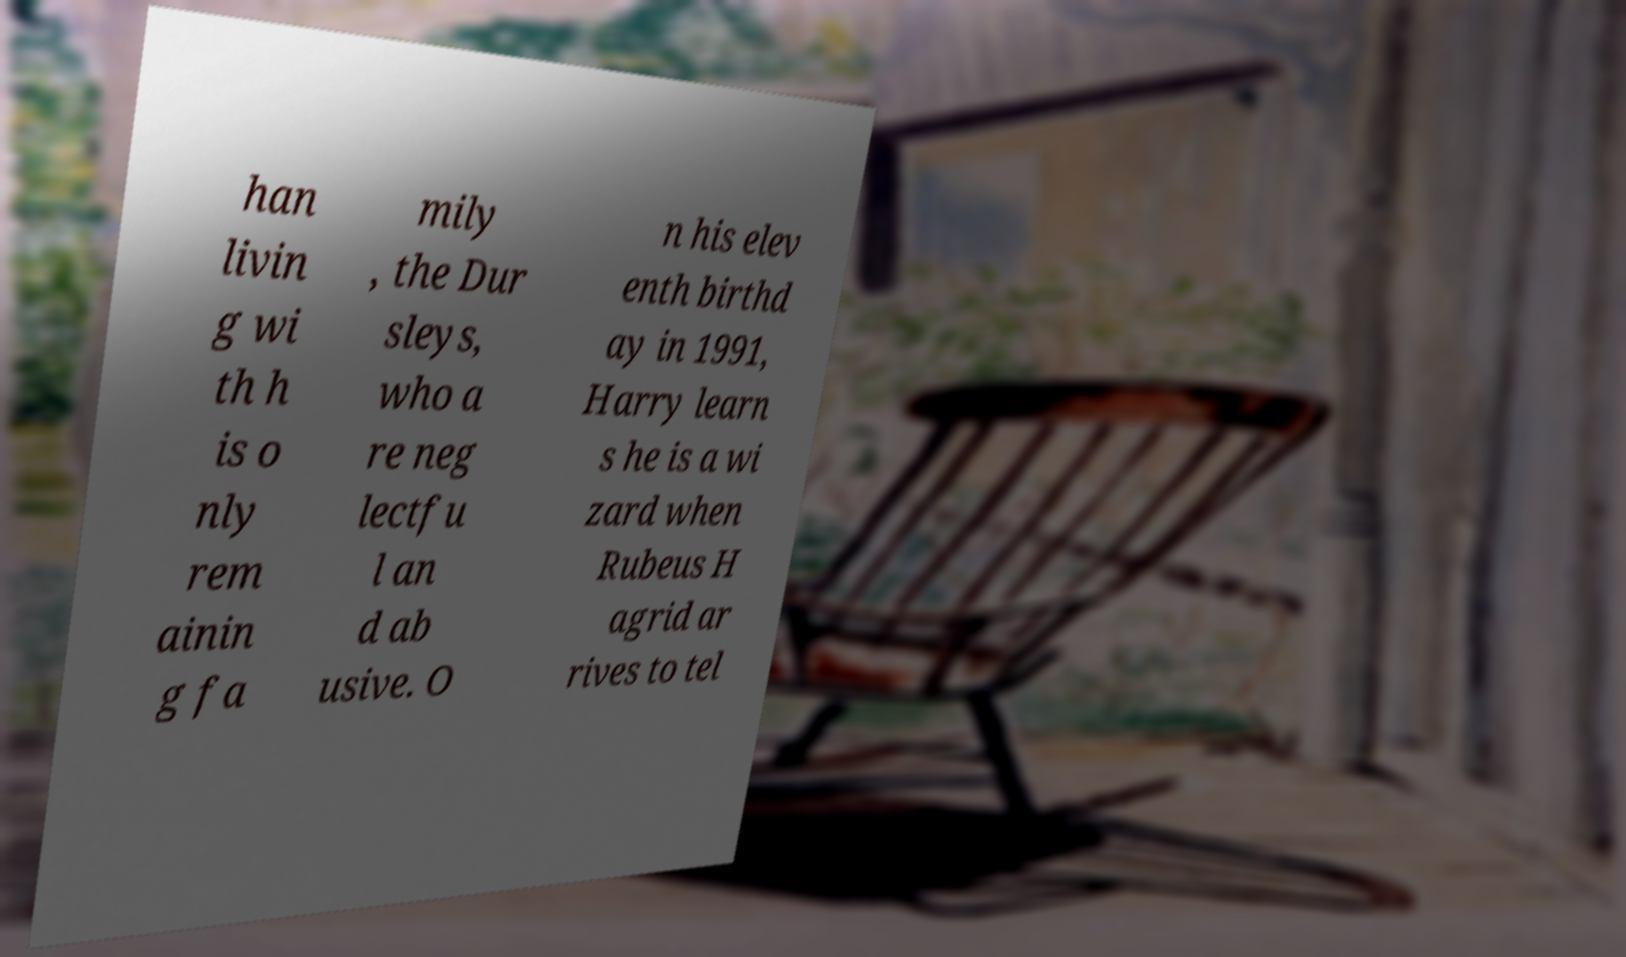There's text embedded in this image that I need extracted. Can you transcribe it verbatim? han livin g wi th h is o nly rem ainin g fa mily , the Dur sleys, who a re neg lectfu l an d ab usive. O n his elev enth birthd ay in 1991, Harry learn s he is a wi zard when Rubeus H agrid ar rives to tel 